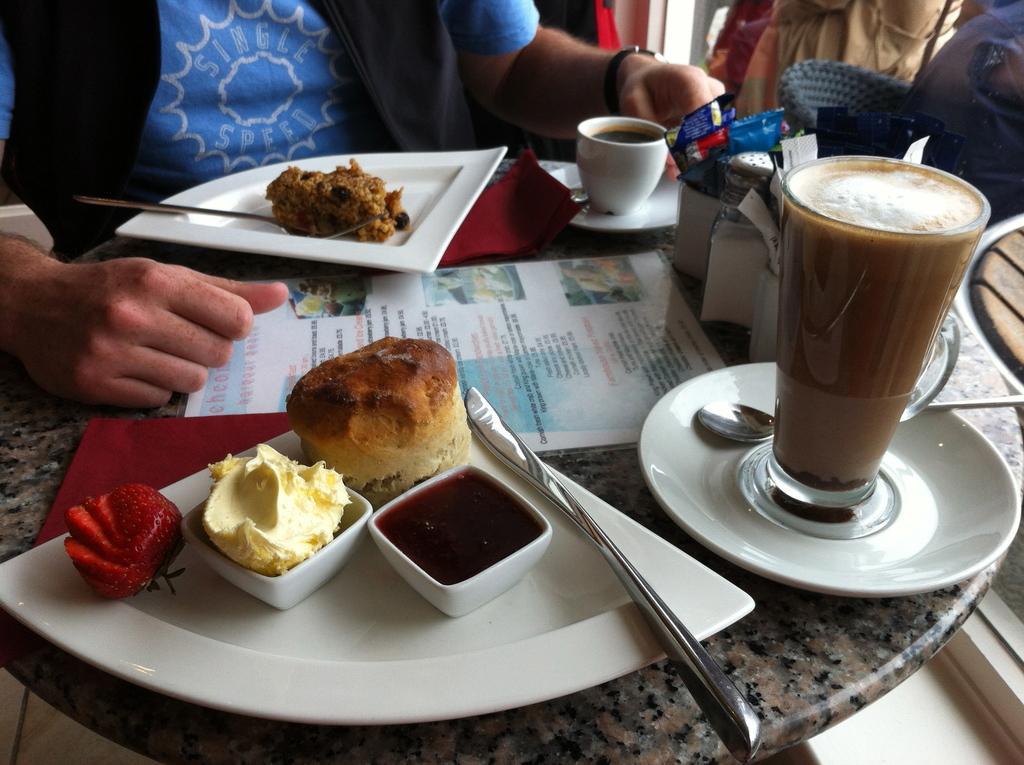Could you give a brief overview of what you see in this image? In the image we can see two persons were sitting on the chair around the table. On table,there is a plate,glass,coffee cup,napkin,ice cream,bread,fruit,sauce and food item. 